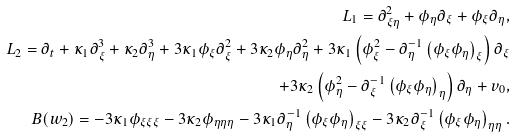Convert formula to latex. <formula><loc_0><loc_0><loc_500><loc_500>L _ { 1 } = \partial _ { \xi \eta } ^ { 2 } + \phi _ { \eta } \partial _ { \xi } + \phi _ { \xi } \partial _ { \eta } , \\ L _ { 2 } = \partial _ { t } + \kappa _ { 1 } \partial _ { \xi } ^ { 3 } + \kappa _ { 2 } \partial _ { \eta } ^ { 3 } + 3 \kappa _ { 1 } \phi _ { \xi } \partial _ { \xi } ^ { 2 } + 3 \kappa _ { 2 } \phi _ { \eta } \partial _ { \eta } ^ { 2 } + 3 \kappa _ { 1 } \left ( \phi _ { \xi } ^ { 2 } - \partial _ { \eta } ^ { - 1 } \left ( \phi _ { \xi } \phi _ { \eta } \right ) _ { \xi } \right ) \partial _ { \xi } \\ + 3 \kappa _ { 2 } \left ( \phi _ { \eta } ^ { 2 } - \partial _ { \xi } ^ { - 1 } \left ( \phi _ { \xi } \phi _ { \eta } \right ) _ { \eta } \right ) \partial _ { \eta } + v _ { 0 } , \\ B ( w _ { 2 } ) = - 3 \kappa _ { 1 } \phi _ { \xi \xi \xi } - 3 \kappa _ { 2 } \phi _ { \eta \eta \eta } - 3 \kappa _ { 1 } \partial _ { \eta } ^ { - 1 } \left ( \phi _ { \xi } \phi _ { \eta } \right ) _ { \xi \xi } - 3 \kappa _ { 2 } \partial _ { \xi } ^ { - 1 } \left ( \phi _ { \xi } \phi _ { \eta } \right ) _ { \eta \eta } .</formula> 